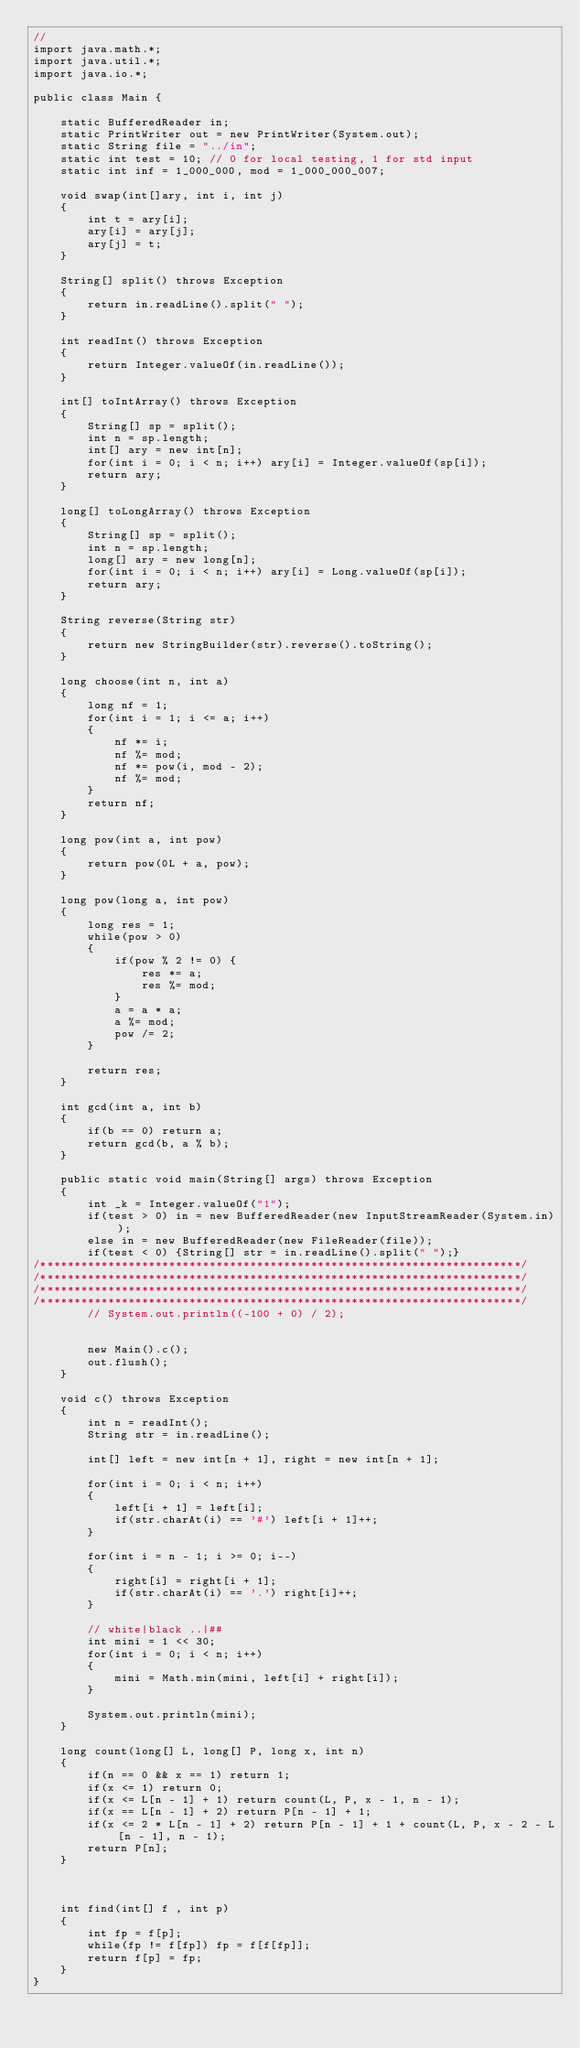<code> <loc_0><loc_0><loc_500><loc_500><_Java_>//
import java.math.*;
import java.util.*;
import java.io.*;
  
public class Main { 
  
    static BufferedReader in;
    static PrintWriter out = new PrintWriter(System.out);
    static String file = "../in";
    static int test = 10; // 0 for local testing, 1 for std input
    static int inf = 1_000_000, mod = 1_000_000_007;

    void swap(int[]ary, int i, int j)
    {
        int t = ary[i];
        ary[i] = ary[j];
        ary[j] = t;
    }
    
    String[] split() throws Exception
    {
        return in.readLine().split(" ");
    }

    int readInt() throws Exception
    {
        return Integer.valueOf(in.readLine());
    }

    int[] toIntArray() throws Exception
    {
        String[] sp = split();
        int n = sp.length;
        int[] ary = new int[n];
        for(int i = 0; i < n; i++) ary[i] = Integer.valueOf(sp[i]);
        return ary;
    }

    long[] toLongArray() throws Exception
    {
        String[] sp = split();
        int n = sp.length;
        long[] ary = new long[n];
        for(int i = 0; i < n; i++) ary[i] = Long.valueOf(sp[i]);
        return ary;
    }

    String reverse(String str)
    {
        return new StringBuilder(str).reverse().toString();
    }

    long choose(int n, int a)
    {
        long nf = 1;
        for(int i = 1; i <= a; i++)
        {
            nf *= i;
            nf %= mod;
            nf *= pow(i, mod - 2);
            nf %= mod;
        }
        return nf;
    }

    long pow(int a, int pow)
    {
        return pow(0L + a, pow);
    }
    
    long pow(long a, int pow)
    {
        long res = 1;
        while(pow > 0)
        {
            if(pow % 2 != 0) {
                res *= a;
                res %= mod;
            }
            a = a * a;
            a %= mod;
            pow /= 2;
        }

        return res;
    }    

    int gcd(int a, int b)
    {
        if(b == 0) return a;
        return gcd(b, a % b);
    }

    public static void main(String[] args) throws Exception
    {
        int _k = Integer.valueOf("1");
        if(test > 0) in = new BufferedReader(new InputStreamReader(System.in));
        else in = new BufferedReader(new FileReader(file));
        if(test < 0) {String[] str = in.readLine().split(" ");}
/***********************************************************************/
/***********************************************************************/
/***********************************************************************/
/***********************************************************************/
        // System.out.println((-100 + 0) / 2);


        new Main().c();
        out.flush();
    }

    void c() throws Exception
    {
        int n = readInt();
        String str = in.readLine();
        
        int[] left = new int[n + 1], right = new int[n + 1];
        
        for(int i = 0; i < n; i++)
        {
            left[i + 1] = left[i];
            if(str.charAt(i) == '#') left[i + 1]++;
        }

        for(int i = n - 1; i >= 0; i--)
        {
            right[i] = right[i + 1];
            if(str.charAt(i) == '.') right[i]++;
        }

        // white|black ..|##
        int mini = 1 << 30;
        for(int i = 0; i < n; i++)
        {
            mini = Math.min(mini, left[i] + right[i]);
        }

        System.out.println(mini);
    }

    long count(long[] L, long[] P, long x, int n)
    {
        if(n == 0 && x == 1) return 1;
        if(x <= 1) return 0;
        if(x <= L[n - 1] + 1) return count(L, P, x - 1, n - 1);
        if(x == L[n - 1] + 2) return P[n - 1] + 1;
        if(x <= 2 * L[n - 1] + 2) return P[n - 1] + 1 + count(L, P, x - 2 - L[n - 1], n - 1);
        return P[n];
    }



    int find(int[] f , int p)
    {
        int fp = f[p];
        while(fp != f[fp]) fp = f[f[fp]];
        return f[p] = fp;
    }
}
</code> 